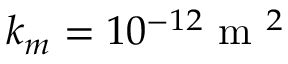Convert formula to latex. <formula><loc_0><loc_0><loc_500><loc_500>k _ { m } = 1 0 ^ { - 1 2 } m ^ { 2 }</formula> 